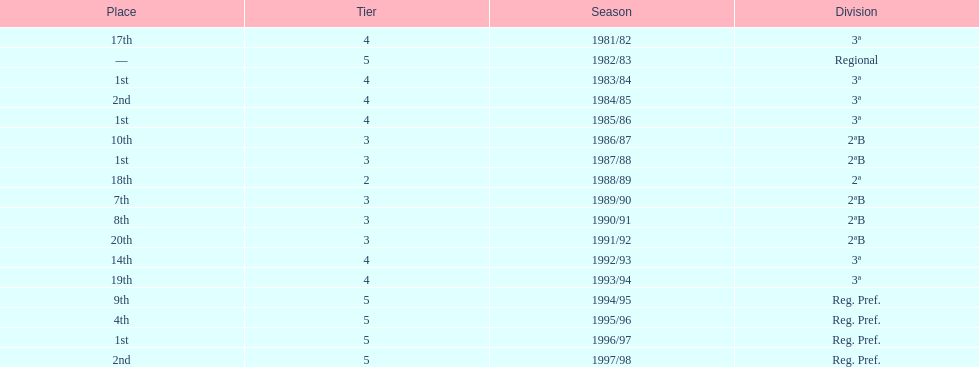When is the last year that the team has been division 2? 1991/92. 